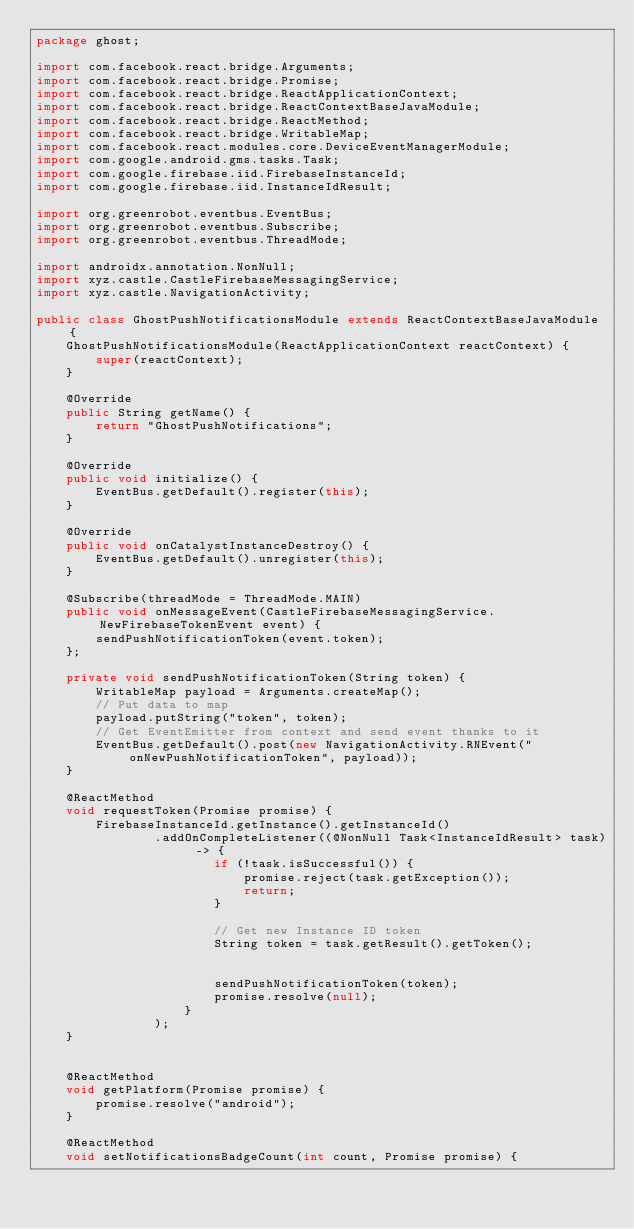<code> <loc_0><loc_0><loc_500><loc_500><_Java_>package ghost;

import com.facebook.react.bridge.Arguments;
import com.facebook.react.bridge.Promise;
import com.facebook.react.bridge.ReactApplicationContext;
import com.facebook.react.bridge.ReactContextBaseJavaModule;
import com.facebook.react.bridge.ReactMethod;
import com.facebook.react.bridge.WritableMap;
import com.facebook.react.modules.core.DeviceEventManagerModule;
import com.google.android.gms.tasks.Task;
import com.google.firebase.iid.FirebaseInstanceId;
import com.google.firebase.iid.InstanceIdResult;

import org.greenrobot.eventbus.EventBus;
import org.greenrobot.eventbus.Subscribe;
import org.greenrobot.eventbus.ThreadMode;

import androidx.annotation.NonNull;
import xyz.castle.CastleFirebaseMessagingService;
import xyz.castle.NavigationActivity;

public class GhostPushNotificationsModule extends ReactContextBaseJavaModule {
    GhostPushNotificationsModule(ReactApplicationContext reactContext) {
        super(reactContext);
    }

    @Override
    public String getName() {
        return "GhostPushNotifications";
    }

    @Override
    public void initialize() {
        EventBus.getDefault().register(this);
    }

    @Override
    public void onCatalystInstanceDestroy() {
        EventBus.getDefault().unregister(this);
    }

    @Subscribe(threadMode = ThreadMode.MAIN)
    public void onMessageEvent(CastleFirebaseMessagingService.NewFirebaseTokenEvent event) {
        sendPushNotificationToken(event.token);
    };

    private void sendPushNotificationToken(String token) {
        WritableMap payload = Arguments.createMap();
        // Put data to map
        payload.putString("token", token);
        // Get EventEmitter from context and send event thanks to it
        EventBus.getDefault().post(new NavigationActivity.RNEvent("onNewPushNotificationToken", payload));
    }

    @ReactMethod
    void requestToken(Promise promise) {
        FirebaseInstanceId.getInstance().getInstanceId()
                .addOnCompleteListener((@NonNull Task<InstanceIdResult> task) -> {
                        if (!task.isSuccessful()) {
                            promise.reject(task.getException());
                            return;
                        }

                        // Get new Instance ID token
                        String token = task.getResult().getToken();


                        sendPushNotificationToken(token);
                        promise.resolve(null);
                    }
                );
    }


    @ReactMethod
    void getPlatform(Promise promise) {
        promise.resolve("android");
    }

    @ReactMethod
    void setNotificationsBadgeCount(int count, Promise promise) {</code> 